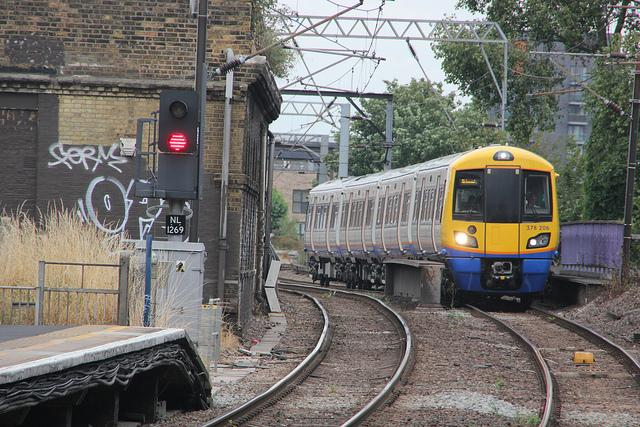This train is moved by what energy?

Choices:
A) magnetic force
B) coal
C) gas
D) electricity electricity 